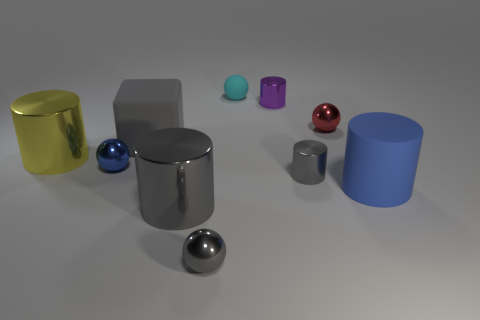Subtract all small purple cylinders. How many cylinders are left? 4 Subtract all gray cylinders. How many cylinders are left? 3 Subtract all blocks. How many objects are left? 9 Add 5 blue metallic balls. How many blue metallic balls are left? 6 Add 8 small blocks. How many small blocks exist? 8 Subtract 0 red cubes. How many objects are left? 10 Subtract 2 spheres. How many spheres are left? 2 Subtract all brown balls. Subtract all purple cubes. How many balls are left? 4 Subtract all yellow blocks. How many gray cylinders are left? 2 Subtract all small brown shiny spheres. Subtract all big yellow cylinders. How many objects are left? 9 